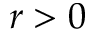Convert formula to latex. <formula><loc_0><loc_0><loc_500><loc_500>r > 0</formula> 